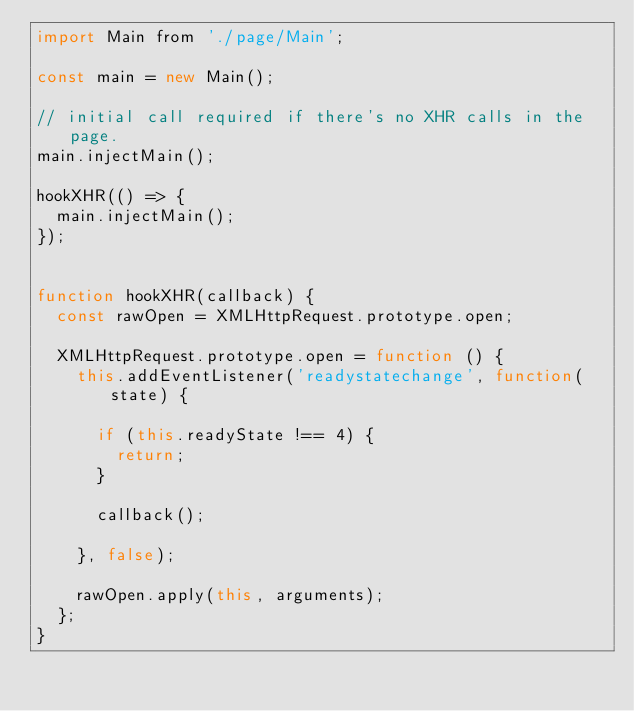Convert code to text. <code><loc_0><loc_0><loc_500><loc_500><_JavaScript_>import Main from './page/Main';

const main = new Main();

// initial call required if there's no XHR calls in the page.
main.injectMain();

hookXHR(() => {
  main.injectMain();
});


function hookXHR(callback) {
  const rawOpen = XMLHttpRequest.prototype.open;

  XMLHttpRequest.prototype.open = function () {
    this.addEventListener('readystatechange', function(state) {

      if (this.readyState !== 4) {
        return;
      }

      callback();

    }, false);

    rawOpen.apply(this, arguments);
  };
}</code> 